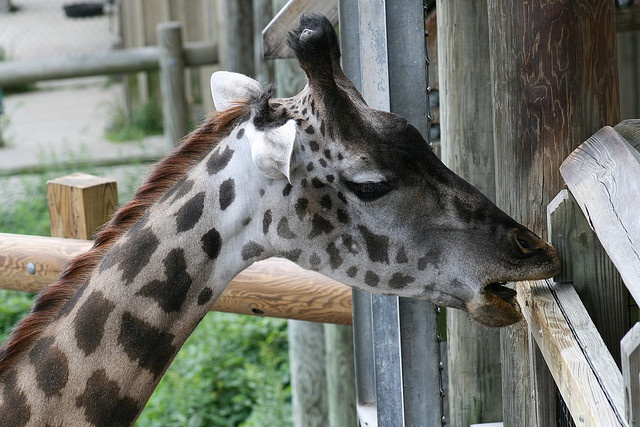Describe the objects in this image and their specific colors. I can see a giraffe in gray, black, darkgray, and lightgray tones in this image. 